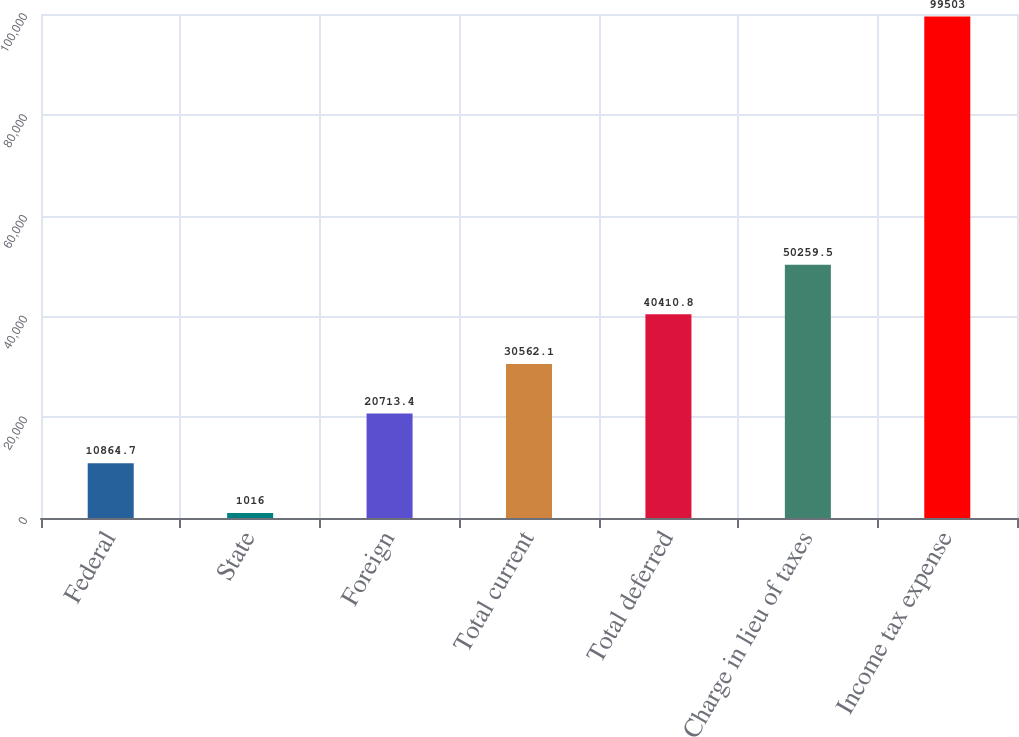Convert chart to OTSL. <chart><loc_0><loc_0><loc_500><loc_500><bar_chart><fcel>Federal<fcel>State<fcel>Foreign<fcel>Total current<fcel>Total deferred<fcel>Charge in lieu of taxes<fcel>Income tax expense<nl><fcel>10864.7<fcel>1016<fcel>20713.4<fcel>30562.1<fcel>40410.8<fcel>50259.5<fcel>99503<nl></chart> 